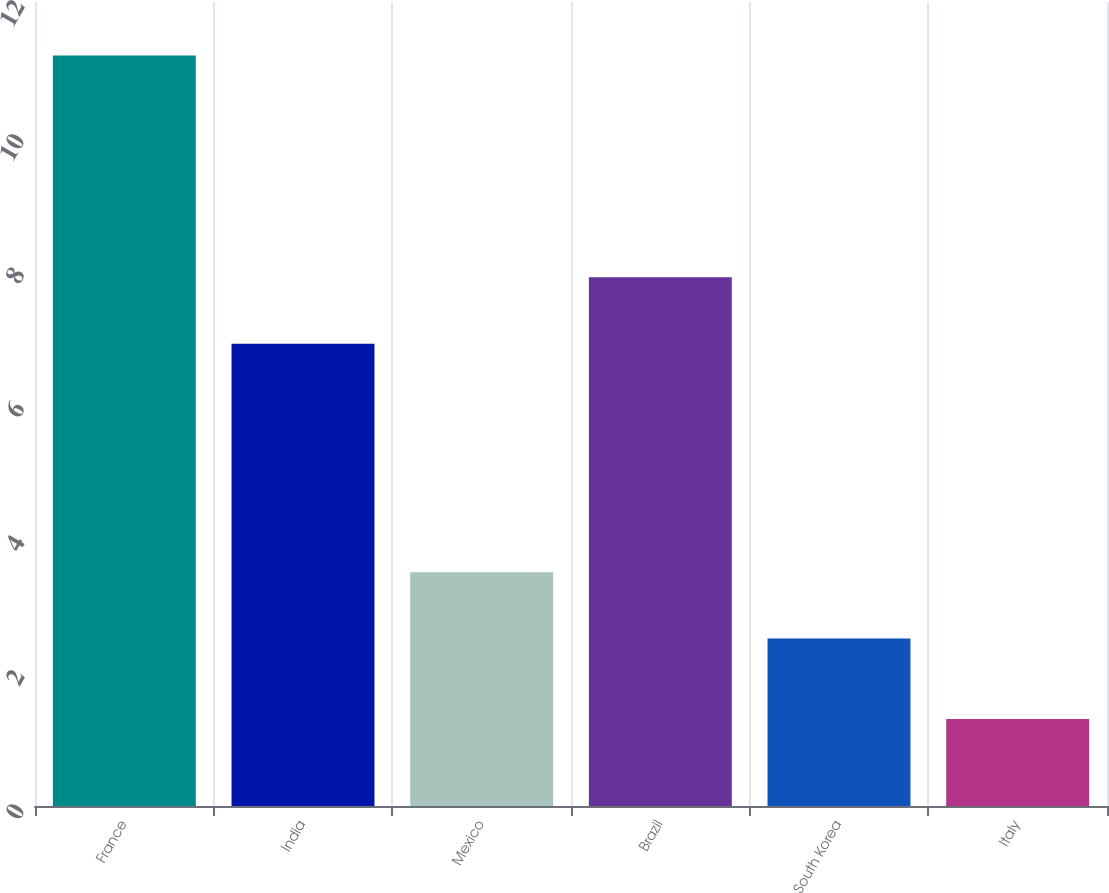Convert chart. <chart><loc_0><loc_0><loc_500><loc_500><bar_chart><fcel>France<fcel>India<fcel>Mexico<fcel>Brazil<fcel>South Korea<fcel>Italy<nl><fcel>11.2<fcel>6.9<fcel>3.49<fcel>7.89<fcel>2.5<fcel>1.3<nl></chart> 